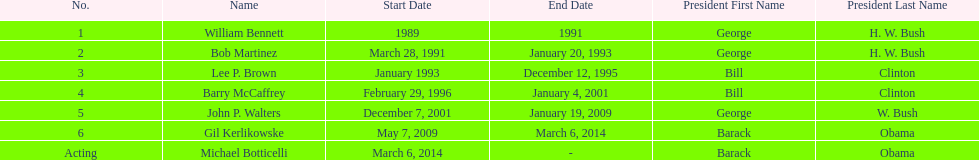How long did the first director serve in office? 2 years. 